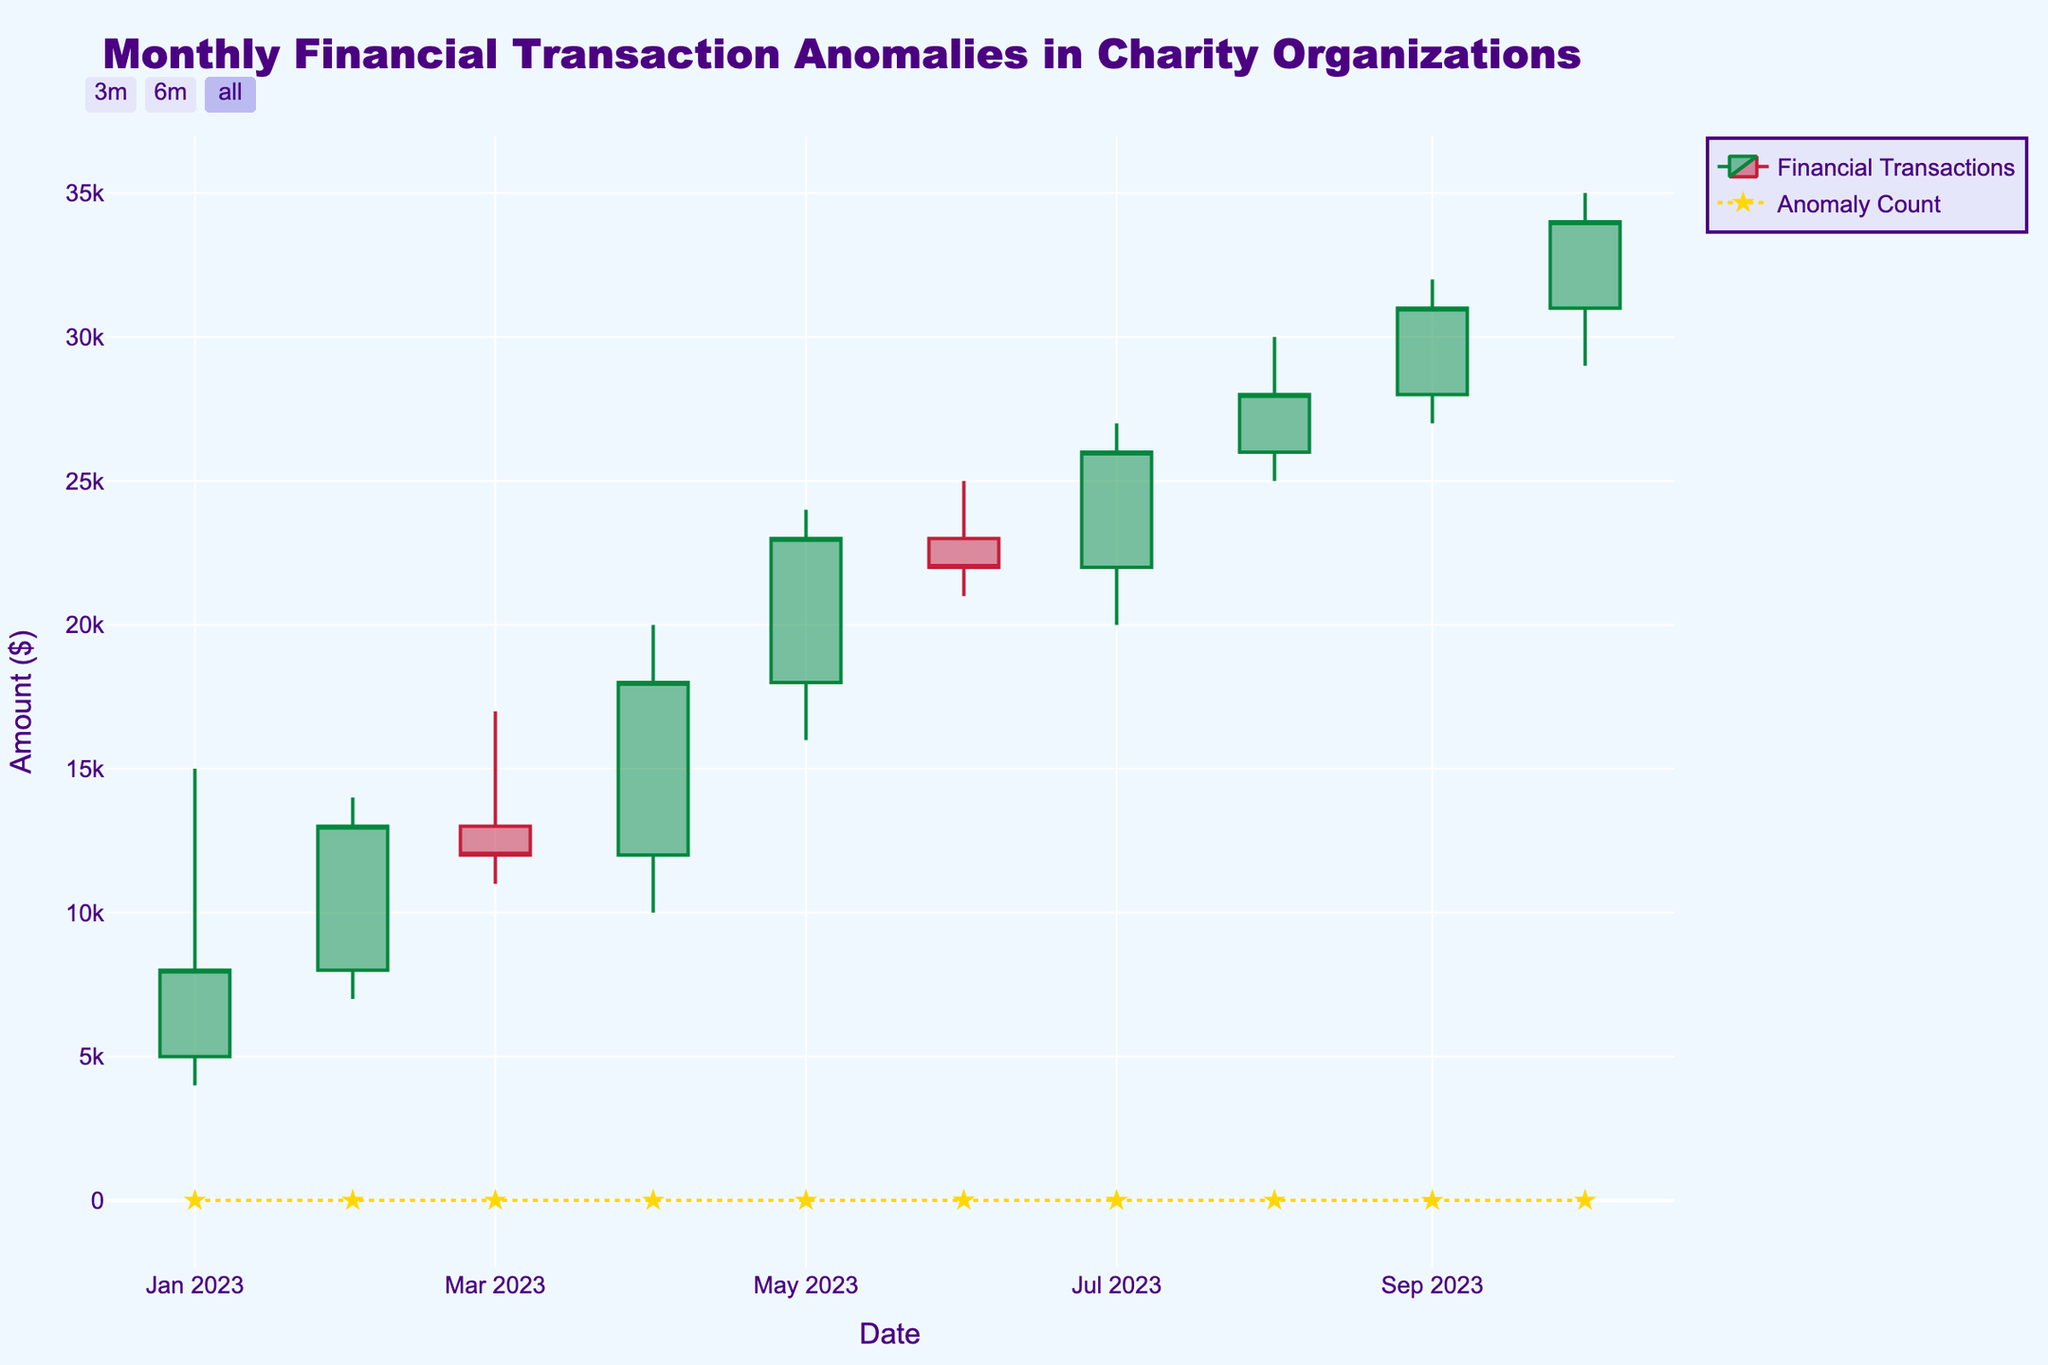What is the title of the plot? The title of the plot is located at the top center of the figure and it indicates the main subject of the plot.
Answer: Monthly Financial Transaction Anomalies in Charity Organizations What is the highest 'High' value recorded, and in which month does it occur? By checking all the 'High' values, we see that the highest 'High' value is 35000 which occurs in October 2023.
Answer: 35000, October What is the lowest 'Low' value recorded in the data, and in which month does it occur? By looking at the 'Low' values, the lowest is 4000 which occurs in January 2023.
Answer: 4000, January Which month shows the highest anomaly count, and what is the value? By checking the 'Anomaly_Count' series, June 2023 shows the highest anomaly count with a value of 9.
Answer: June, 9 How does the 'Open' value in February compare to the 'Close' value in January? The 'Open' value in February is 8000, whereas the 'Close' value in January is also 8000. So, they are equal.
Answer: Equal What is the difference between the 'High' and 'Low' values in April? The 'High' value in April is 20000 and the 'Low' value is 10000. The difference is 20000 - 10000 = 10000.
Answer: 10000 How does the trend of closing values from January to October look? By examining the 'Close' values from January (8000) to October (34000), we see a general increasing trend with minor fluctuations.
Answer: Increasing trend In which month does the 'Close' value first exceed 20000? The 'Close' value first exceeds 20000 in May 2023, with a value of 23000.
Answer: May Between which two months is the biggest jump in 'Close' values observed? The biggest jump in 'Close' values is between June (22000) and July (26000), a difference of 4000.
Answer: June to July How does the anomaly count correlate with the trend in 'Close' values? Examining the 'Close' values and the scatter plot for anomaly counts, higher anomaly counts seem to coincide with months where 'Close' values display significant changes, either upward or downward.
Answer: Higher anomaly counts align with significant changes 